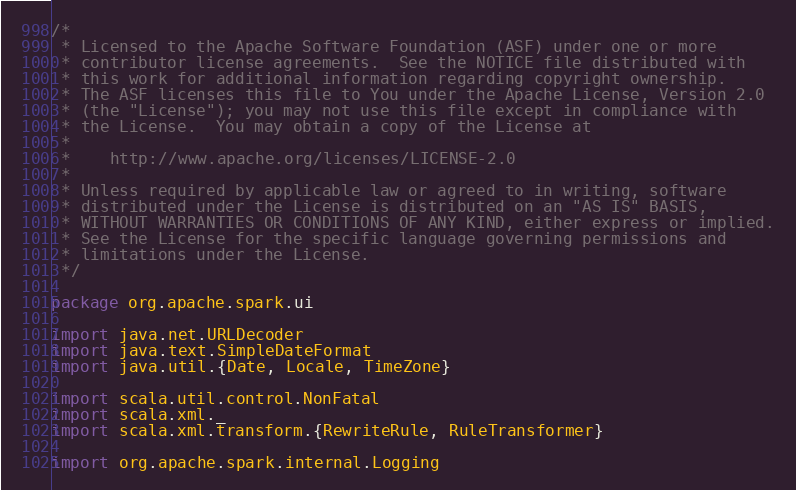<code> <loc_0><loc_0><loc_500><loc_500><_Scala_>/*
 * Licensed to the Apache Software Foundation (ASF) under one or more
 * contributor license agreements.  See the NOTICE file distributed with
 * this work for additional information regarding copyright ownership.
 * The ASF licenses this file to You under the Apache License, Version 2.0
 * (the "License"); you may not use this file except in compliance with
 * the License.  You may obtain a copy of the License at
 *
 *    http://www.apache.org/licenses/LICENSE-2.0
 *
 * Unless required by applicable law or agreed to in writing, software
 * distributed under the License is distributed on an "AS IS" BASIS,
 * WITHOUT WARRANTIES OR CONDITIONS OF ANY KIND, either express or implied.
 * See the License for the specific language governing permissions and
 * limitations under the License.
 */

package org.apache.spark.ui

import java.net.URLDecoder
import java.text.SimpleDateFormat
import java.util.{Date, Locale, TimeZone}

import scala.util.control.NonFatal
import scala.xml._
import scala.xml.transform.{RewriteRule, RuleTransformer}

import org.apache.spark.internal.Logging</code> 